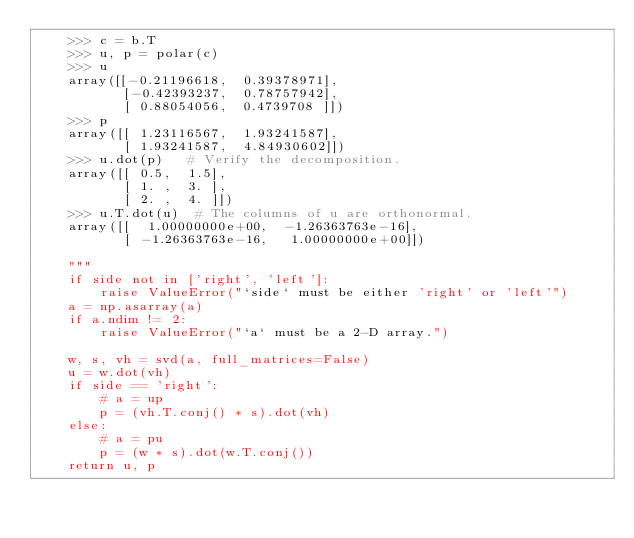Convert code to text. <code><loc_0><loc_0><loc_500><loc_500><_Python_>    >>> c = b.T
    >>> u, p = polar(c)
    >>> u
    array([[-0.21196618,  0.39378971],
           [-0.42393237,  0.78757942],
           [ 0.88054056,  0.4739708 ]])
    >>> p
    array([[ 1.23116567,  1.93241587],
           [ 1.93241587,  4.84930602]])
    >>> u.dot(p)   # Verify the decomposition.
    array([[ 0.5,  1.5],
           [ 1. ,  3. ],
           [ 2. ,  4. ]])
    >>> u.T.dot(u)  # The columns of u are orthonormal.
    array([[  1.00000000e+00,  -1.26363763e-16],
           [ -1.26363763e-16,   1.00000000e+00]])

    """
    if side not in ['right', 'left']:
        raise ValueError("`side` must be either 'right' or 'left'")
    a = np.asarray(a)
    if a.ndim != 2:
        raise ValueError("`a` must be a 2-D array.")

    w, s, vh = svd(a, full_matrices=False)
    u = w.dot(vh)
    if side == 'right':
        # a = up
        p = (vh.T.conj() * s).dot(vh)
    else:
        # a = pu
        p = (w * s).dot(w.T.conj())
    return u, p
</code> 